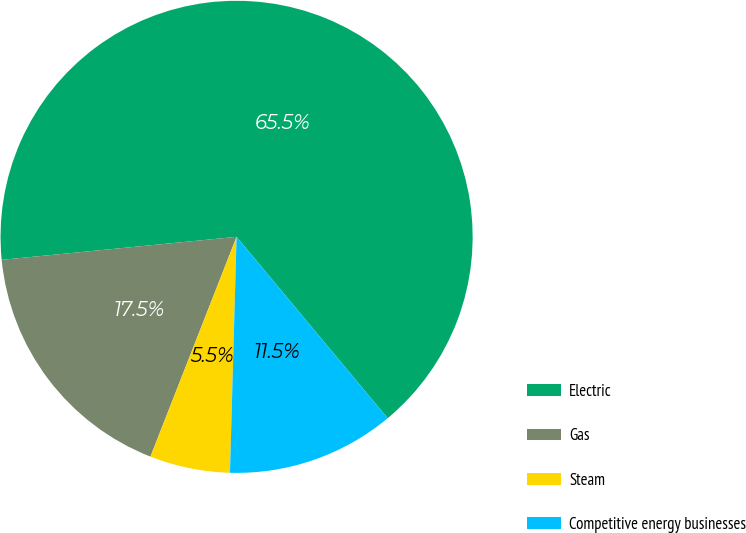Convert chart. <chart><loc_0><loc_0><loc_500><loc_500><pie_chart><fcel>Electric<fcel>Gas<fcel>Steam<fcel>Competitive energy businesses<nl><fcel>65.5%<fcel>17.5%<fcel>5.5%<fcel>11.5%<nl></chart> 